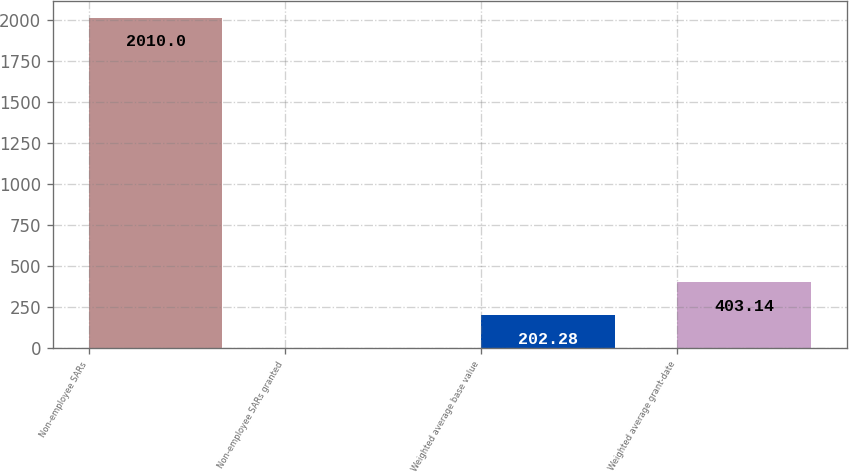Convert chart to OTSL. <chart><loc_0><loc_0><loc_500><loc_500><bar_chart><fcel>Non-employee SARs<fcel>Non-employee SARs granted<fcel>Weighted average base value<fcel>Weighted average grant-date<nl><fcel>2010<fcel>1.42<fcel>202.28<fcel>403.14<nl></chart> 